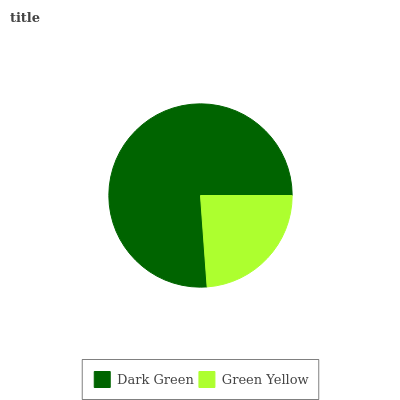Is Green Yellow the minimum?
Answer yes or no. Yes. Is Dark Green the maximum?
Answer yes or no. Yes. Is Green Yellow the maximum?
Answer yes or no. No. Is Dark Green greater than Green Yellow?
Answer yes or no. Yes. Is Green Yellow less than Dark Green?
Answer yes or no. Yes. Is Green Yellow greater than Dark Green?
Answer yes or no. No. Is Dark Green less than Green Yellow?
Answer yes or no. No. Is Dark Green the high median?
Answer yes or no. Yes. Is Green Yellow the low median?
Answer yes or no. Yes. Is Green Yellow the high median?
Answer yes or no. No. Is Dark Green the low median?
Answer yes or no. No. 